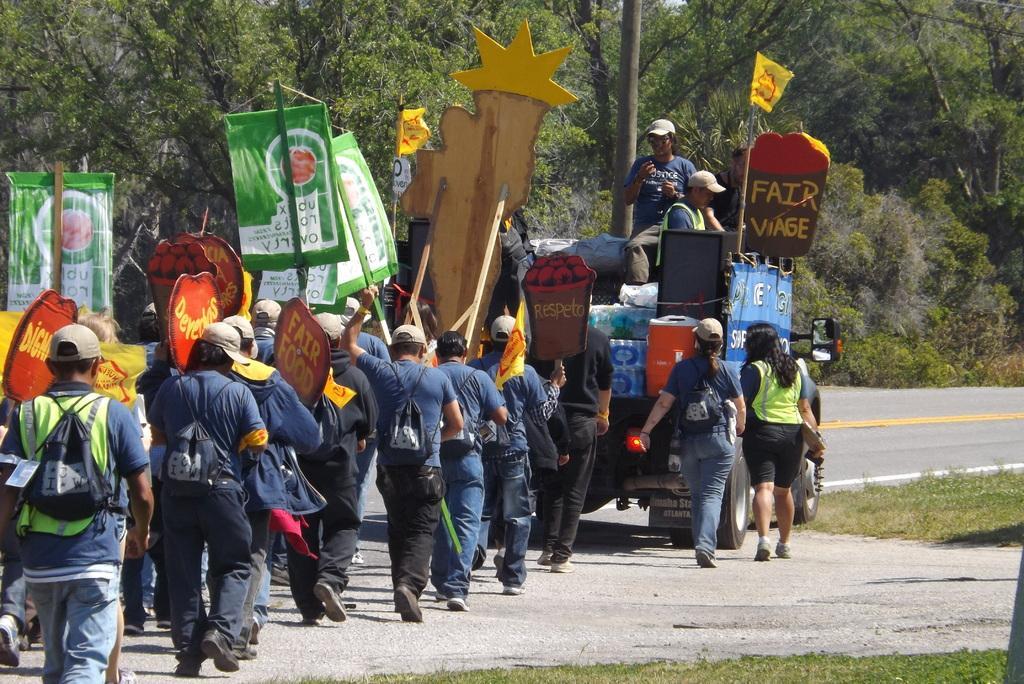Could you give a brief overview of what you see in this image? In this image I see number of people in which most of them are holding a stick on which there are banners and boards and I see a vehicle over here on which there are 2 persons and few things and I see that there are words written on banners and I see 2 yellow color flags over here and I see the road and the grass. In the background I see the trees. 